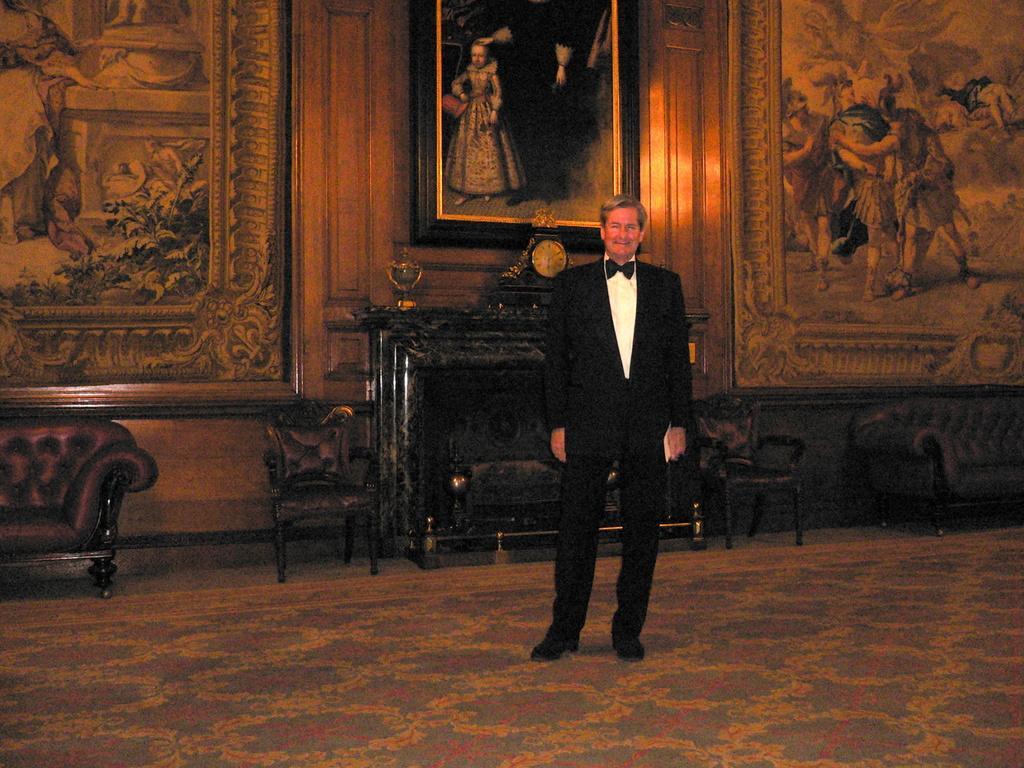Can you describe this image briefly? This is the picture of a man in black blazer standing on the floor. Background of the man is a wall with paintings and photo frames. 